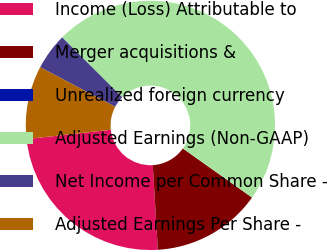Convert chart to OTSL. <chart><loc_0><loc_0><loc_500><loc_500><pie_chart><fcel>Income (Loss) Attributable to<fcel>Merger acquisitions &<fcel>Unrealized foreign currency<fcel>Adjusted Earnings (Non-GAAP)<fcel>Net Income per Common Share -<fcel>Adjusted Earnings Per Share -<nl><fcel>24.2%<fcel>14.21%<fcel>0.01%<fcel>47.35%<fcel>4.75%<fcel>9.48%<nl></chart> 